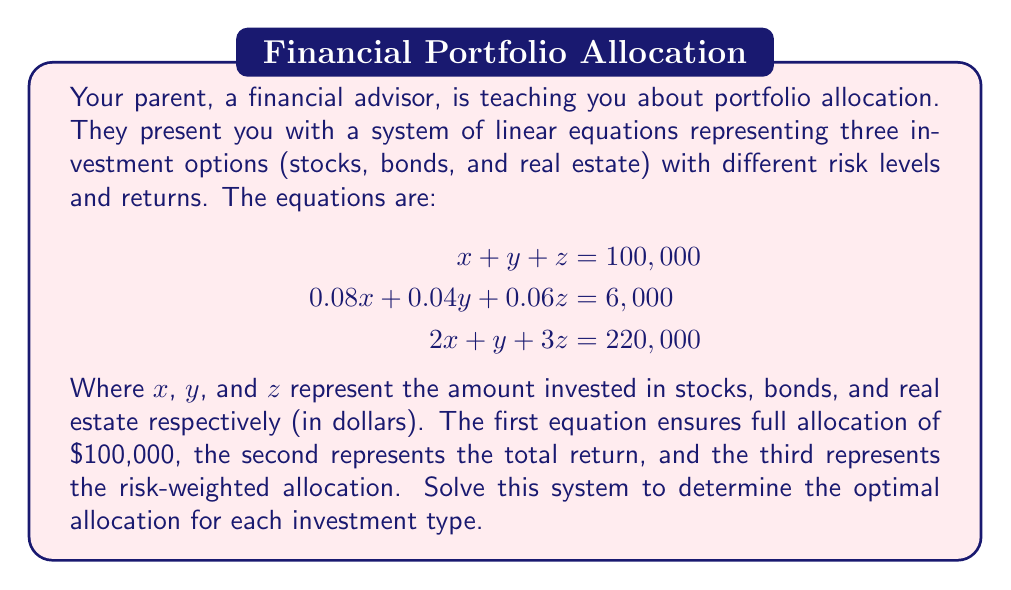Can you answer this question? Let's solve this system of linear equations using the elimination method:

1) First, let's multiply the first equation by 0.08 to match the coefficient of x in the second equation:

   $$\begin{aligned}
   0.08x + 0.08y + 0.08z &= 8,000 \\
   0.08x + 0.04y + 0.06z &= 6,000
   \end{aligned}$$

2) Subtracting the second equation from this new equation:

   $$0.04y + 0.02z = 2,000 \quad (Equation 4)$$

3) Now, let's multiply the first equation by 2 to match the coefficient of x in the third equation:

   $$\begin{aligned}
   2x + 2y + 2z &= 200,000 \\
   2x + y + 3z &= 220,000
   \end{aligned}$$

4) Subtracting the third equation from this new equation:

   $$y - z = -20,000 \quad (Equation 5)$$

5) From Equation 5, we can express y in terms of z:

   $$y = z - 20,000 \quad (Equation 6)$$

6) Substituting this into Equation 4:

   $$0.04(z - 20,000) + 0.02z = 2,000$$
   $$0.04z - 800 + 0.02z = 2,000$$
   $$0.06z = 2,800$$
   $$z = 46,666.67$$

7) Substituting this value of z back into Equation 6:

   $$y = 46,666.67 - 20,000 = 26,666.67$$

8) Finally, we can find x using the first equation:

   $$x + 26,666.67 + 46,666.67 = 100,000$$
   $$x = 26,666.67$$

Therefore, the optimal allocation is:
Stocks (x): $26,666.67
Bonds (y): $26,666.67
Real Estate (z): $46,666.67
Answer: Stocks: $26,666.67, Bonds: $26,666.67, Real Estate: $46,666.67 